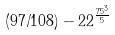Convert formula to latex. <formula><loc_0><loc_0><loc_500><loc_500>( 9 7 / 1 0 8 ) - 2 2 ^ { \frac { 7 5 ^ { 3 } } { 5 } }</formula> 